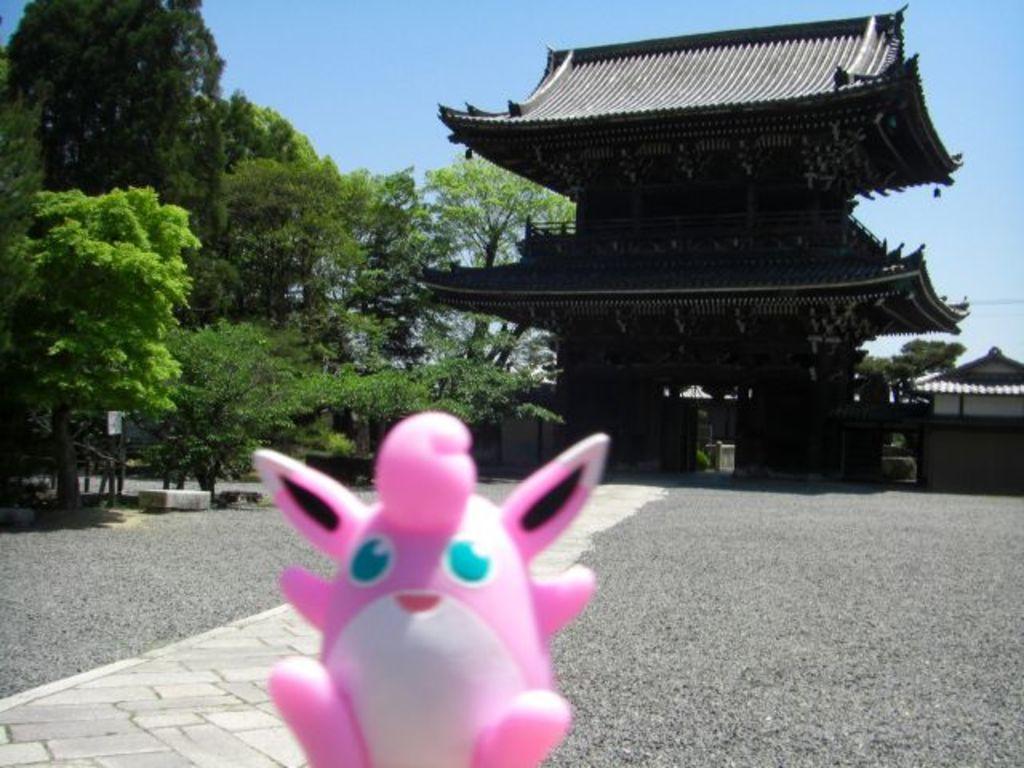Please provide a concise description of this image. In this image we can see a toy. Behind the toy we can see a group of trees and a house. At the top we can see the sky. 